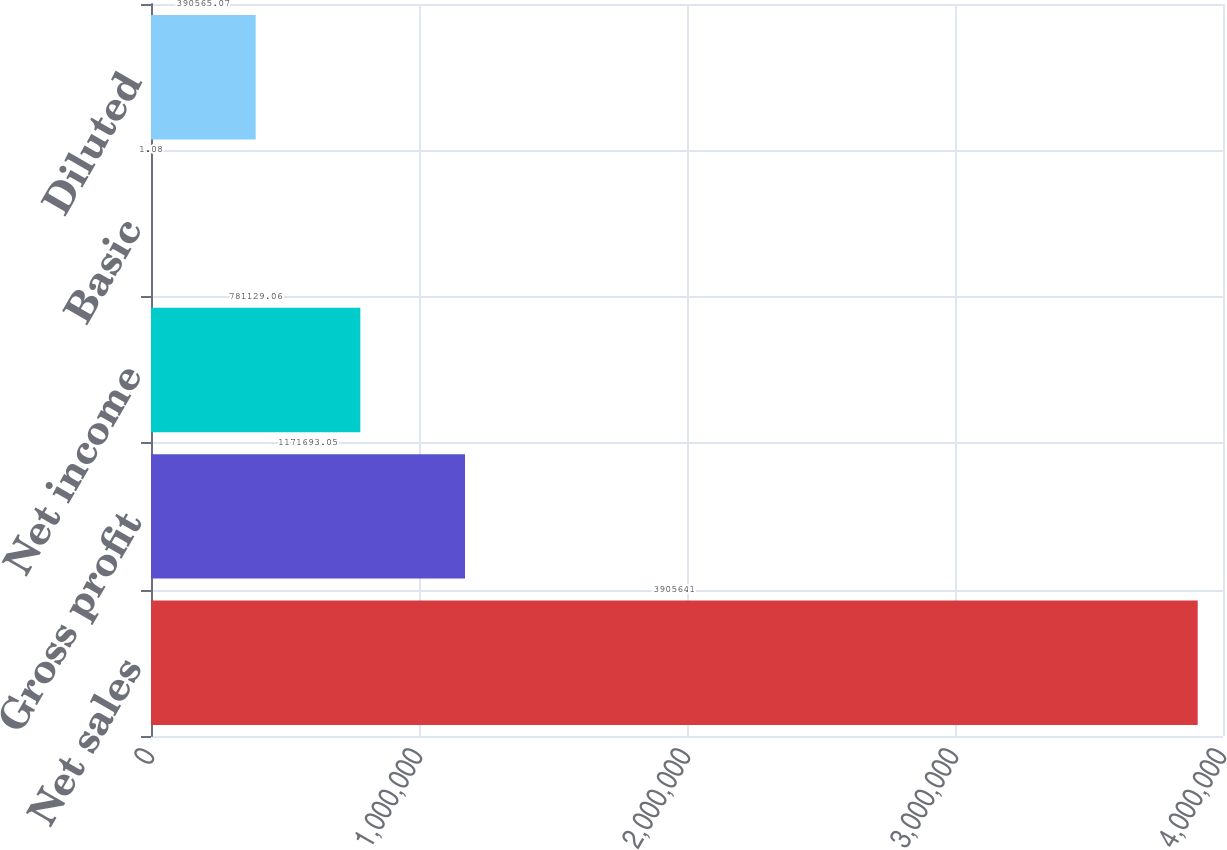<chart> <loc_0><loc_0><loc_500><loc_500><bar_chart><fcel>Net sales<fcel>Gross profit<fcel>Net income<fcel>Basic<fcel>Diluted<nl><fcel>3.90564e+06<fcel>1.17169e+06<fcel>781129<fcel>1.08<fcel>390565<nl></chart> 